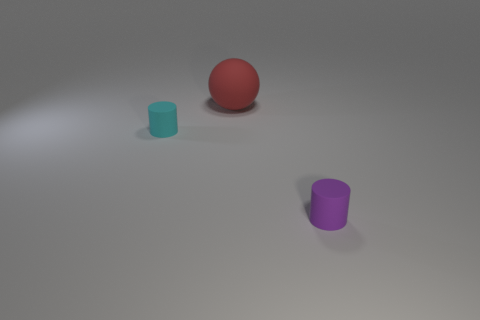Is the number of tiny cyan matte cylinders to the right of the tiny purple matte thing less than the number of tiny matte cylinders in front of the cyan cylinder?
Your answer should be compact. Yes. What is the size of the cyan thing that is the same material as the sphere?
Give a very brief answer. Small. Does the purple cylinder have the same material as the cylinder that is behind the small purple thing?
Offer a terse response. Yes. There is a cyan object that is the same shape as the tiny purple matte thing; what is its material?
Your answer should be compact. Rubber. The matte thing that is in front of the cyan matte thing behind the cylinder that is to the right of the big rubber thing is what color?
Keep it short and to the point. Purple. What number of other objects are there of the same shape as the cyan thing?
Your response must be concise. 1. How many objects are either big green balls or cylinders that are to the left of the big red thing?
Make the answer very short. 1. Is there a cyan object that has the same size as the red ball?
Your answer should be compact. No. Do the red thing and the cyan cylinder have the same material?
Provide a succinct answer. Yes. What number of things are yellow metal cylinders or cylinders?
Offer a terse response. 2. 